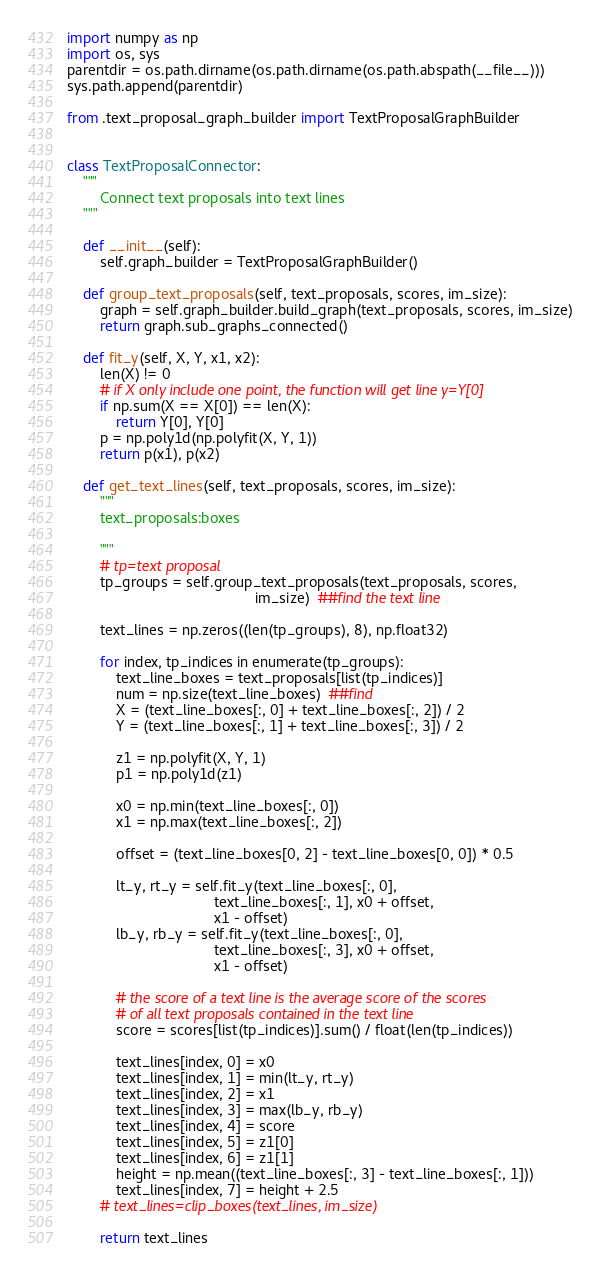Convert code to text. <code><loc_0><loc_0><loc_500><loc_500><_Python_>import numpy as np
import os, sys
parentdir = os.path.dirname(os.path.dirname(os.path.abspath(__file__)))
sys.path.append(parentdir)

from .text_proposal_graph_builder import TextProposalGraphBuilder


class TextProposalConnector:
    """
        Connect text proposals into text lines
    """

    def __init__(self):
        self.graph_builder = TextProposalGraphBuilder()

    def group_text_proposals(self, text_proposals, scores, im_size):
        graph = self.graph_builder.build_graph(text_proposals, scores, im_size)
        return graph.sub_graphs_connected()

    def fit_y(self, X, Y, x1, x2):
        len(X) != 0
        # if X only include one point, the function will get line y=Y[0]
        if np.sum(X == X[0]) == len(X):
            return Y[0], Y[0]
        p = np.poly1d(np.polyfit(X, Y, 1))
        return p(x1), p(x2)

    def get_text_lines(self, text_proposals, scores, im_size):
        """
        text_proposals:boxes
        
        """
        # tp=text proposal
        tp_groups = self.group_text_proposals(text_proposals, scores,
                                              im_size)  ##find the text line

        text_lines = np.zeros((len(tp_groups), 8), np.float32)

        for index, tp_indices in enumerate(tp_groups):
            text_line_boxes = text_proposals[list(tp_indices)]
            num = np.size(text_line_boxes)  ##find
            X = (text_line_boxes[:, 0] + text_line_boxes[:, 2]) / 2
            Y = (text_line_boxes[:, 1] + text_line_boxes[:, 3]) / 2

            z1 = np.polyfit(X, Y, 1)
            p1 = np.poly1d(z1)

            x0 = np.min(text_line_boxes[:, 0])
            x1 = np.max(text_line_boxes[:, 2])

            offset = (text_line_boxes[0, 2] - text_line_boxes[0, 0]) * 0.5

            lt_y, rt_y = self.fit_y(text_line_boxes[:, 0],
                                    text_line_boxes[:, 1], x0 + offset,
                                    x1 - offset)
            lb_y, rb_y = self.fit_y(text_line_boxes[:, 0],
                                    text_line_boxes[:, 3], x0 + offset,
                                    x1 - offset)

            # the score of a text line is the average score of the scores
            # of all text proposals contained in the text line
            score = scores[list(tp_indices)].sum() / float(len(tp_indices))

            text_lines[index, 0] = x0
            text_lines[index, 1] = min(lt_y, rt_y)
            text_lines[index, 2] = x1
            text_lines[index, 3] = max(lb_y, rb_y)
            text_lines[index, 4] = score
            text_lines[index, 5] = z1[0]
            text_lines[index, 6] = z1[1]
            height = np.mean((text_line_boxes[:, 3] - text_line_boxes[:, 1]))
            text_lines[index, 7] = height + 2.5
        # text_lines=clip_boxes(text_lines, im_size)

        return text_lines
</code> 